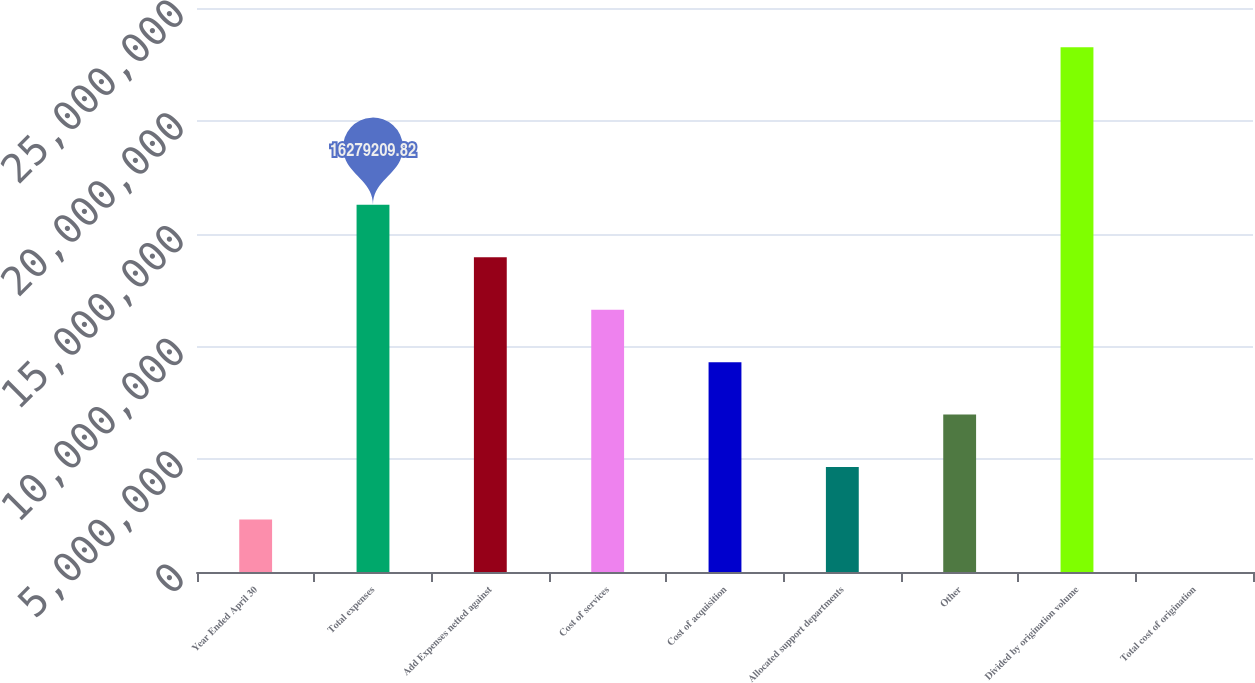Convert chart to OTSL. <chart><loc_0><loc_0><loc_500><loc_500><bar_chart><fcel>Year Ended April 30<fcel>Total expenses<fcel>Add Expenses netted against<fcel>Cost of services<fcel>Cost of acquisition<fcel>Allocated support departments<fcel>Other<fcel>Divided by origination volume<fcel>Total cost of origination<nl><fcel>2.3256e+06<fcel>1.62792e+07<fcel>1.39536e+07<fcel>1.1628e+07<fcel>9.30241e+06<fcel>4.6512e+06<fcel>6.97681e+06<fcel>2.3256e+07<fcel>2.33<nl></chart> 